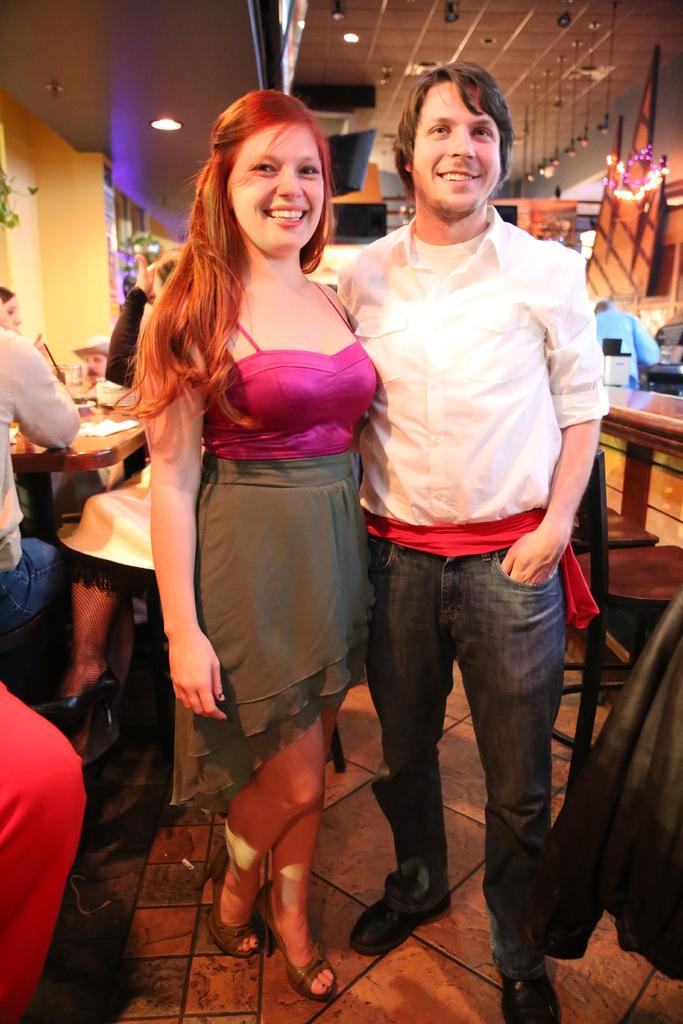Who is present in the image? There is a man and a woman in the image. What are the expressions on their faces? Both the man and the woman are smiling. What type of furniture can be seen in the image? There are tables and chairs in the image. Are the chairs occupied? Yes, there are people seated on the chairs. How many cows can be seen grazing near the gate in the image? There are no cows or gates present in the image. What is the distribution of the chairs in the image? The chairs are arranged around the tables in the image, but there is no specific distribution pattern mentioned. 